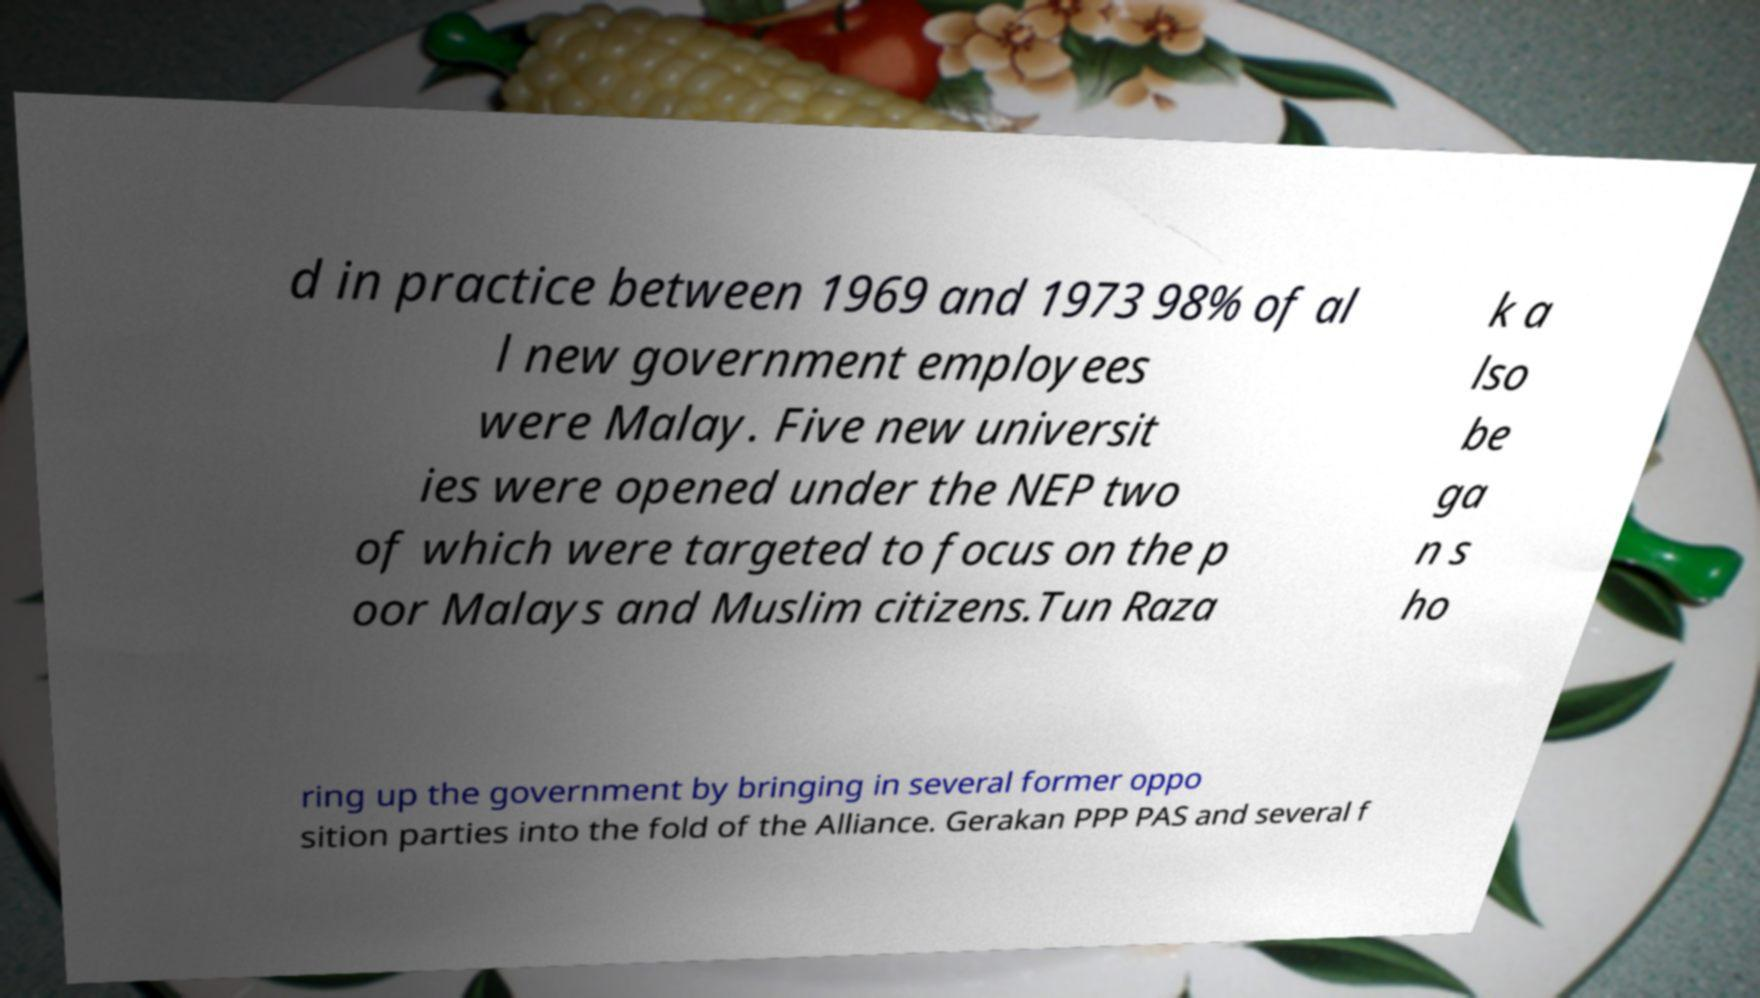I need the written content from this picture converted into text. Can you do that? d in practice between 1969 and 1973 98% of al l new government employees were Malay. Five new universit ies were opened under the NEP two of which were targeted to focus on the p oor Malays and Muslim citizens.Tun Raza k a lso be ga n s ho ring up the government by bringing in several former oppo sition parties into the fold of the Alliance. Gerakan PPP PAS and several f 